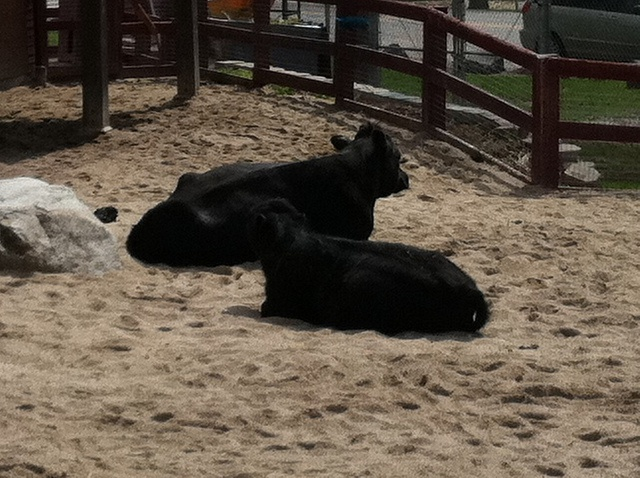Describe the objects in this image and their specific colors. I can see cow in black and gray tones, cow in black, gray, and darkgray tones, and car in black and gray tones in this image. 